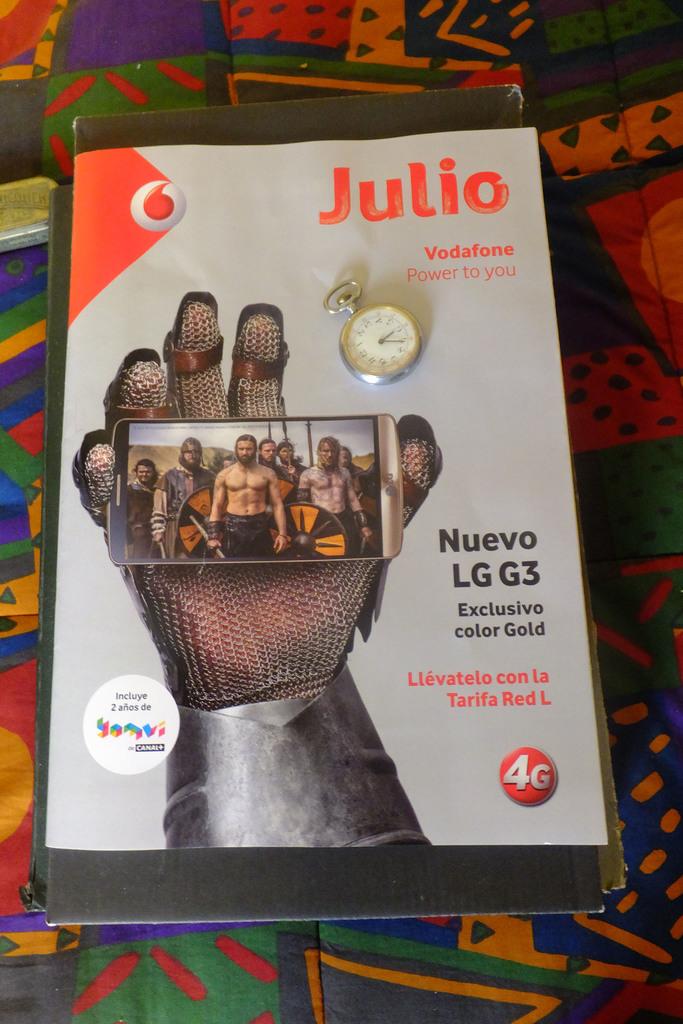What is the name of the magazine?
Your answer should be very brief. Julio. 